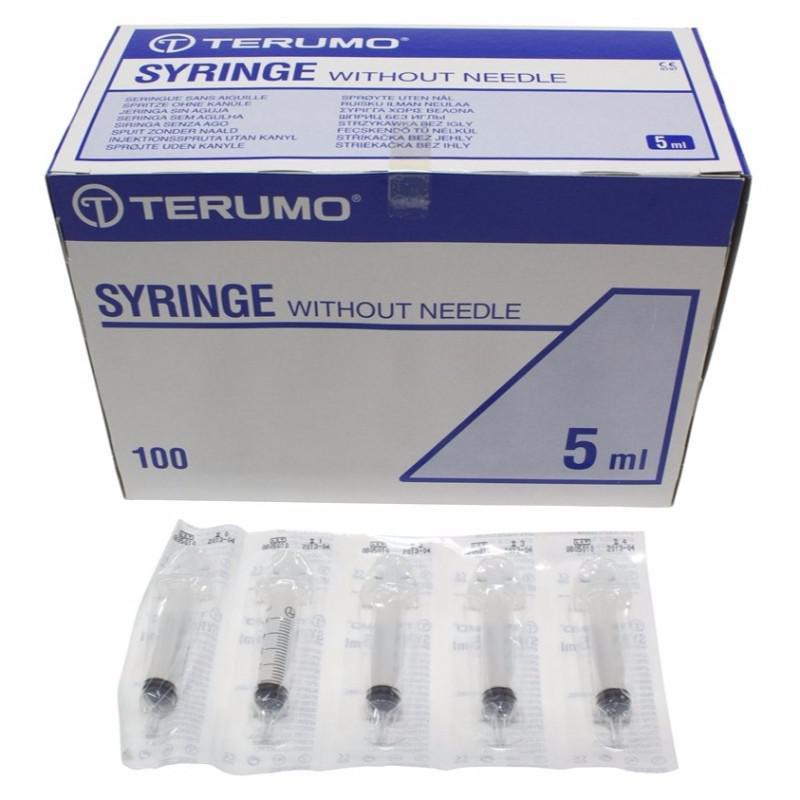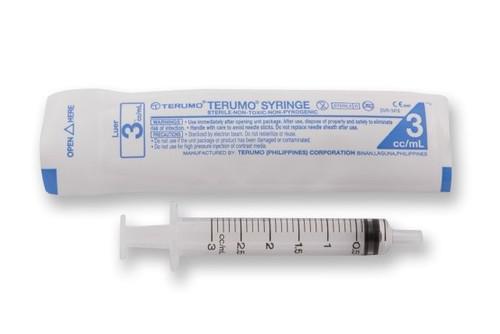The first image is the image on the left, the second image is the image on the right. Considering the images on both sides, is "At least one packaged syringe is in front of a box, in one image." valid? Answer yes or no. Yes. The first image is the image on the left, the second image is the image on the right. Considering the images on both sides, is "The left image has at least one syringe laying down in front of a box." valid? Answer yes or no. Yes. 